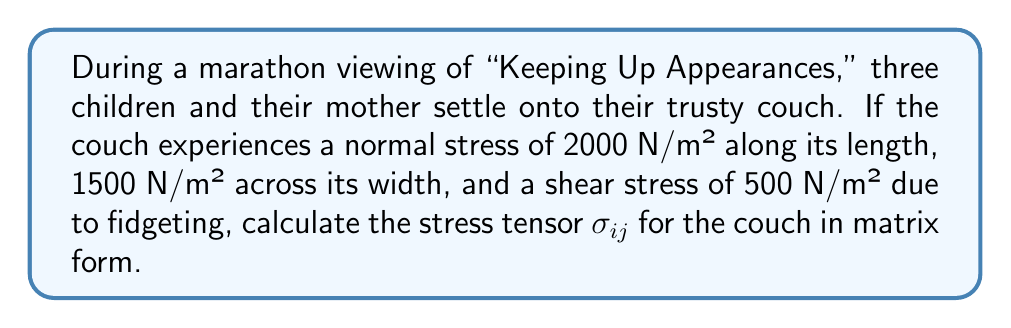Provide a solution to this math problem. Let's approach this step-by-step:

1) The stress tensor $\sigma_{ij}$ is a 3x3 matrix that represents the state of stress at a point in the material (in this case, the couch).

2) In a 3D Cartesian coordinate system, the stress tensor is given by:

   $$\sigma_{ij} = \begin{bmatrix}
   \sigma_{xx} & \tau_{xy} & \tau_{xz} \\
   \tau_{yx} & \sigma_{yy} & \tau_{yz} \\
   \tau_{zx} & \tau_{zy} & \sigma_{zz}
   \end{bmatrix}$$

   Where:
   - $\sigma_{xx}$, $\sigma_{yy}$, $\sigma_{zz}$ are normal stresses
   - $\tau_{xy}$, $\tau_{yz}$, $\tau_{xz}$, $\tau_{yx}$, $\tau_{zy}$, $\tau_{zx}$ are shear stresses

3) From the given information:
   - Normal stress along the length (x-direction): $\sigma_{xx} = 2000$ N/m²
   - Normal stress across the width (y-direction): $\sigma_{yy} = 1500$ N/m²
   - Shear stress due to fidgeting: $\tau_{xy} = \tau_{yx} = 500$ N/m²

4) We assume no stress in the z-direction (vertical) and no other shear stresses, so:
   $\sigma_{zz} = \tau_{xz} = \tau_{yz} = \tau_{zx} = \tau_{zy} = 0$

5) Therefore, the stress tensor for the couch is:

   $$\sigma_{ij} = \begin{bmatrix}
   2000 & 500 & 0 \\
   500 & 1500 & 0 \\
   0 & 0 & 0
   \end{bmatrix}$$ N/m²
Answer: $$\sigma_{ij} = \begin{bmatrix}
2000 & 500 & 0 \\
500 & 1500 & 0 \\
0 & 0 & 0
\end{bmatrix}$$ N/m² 